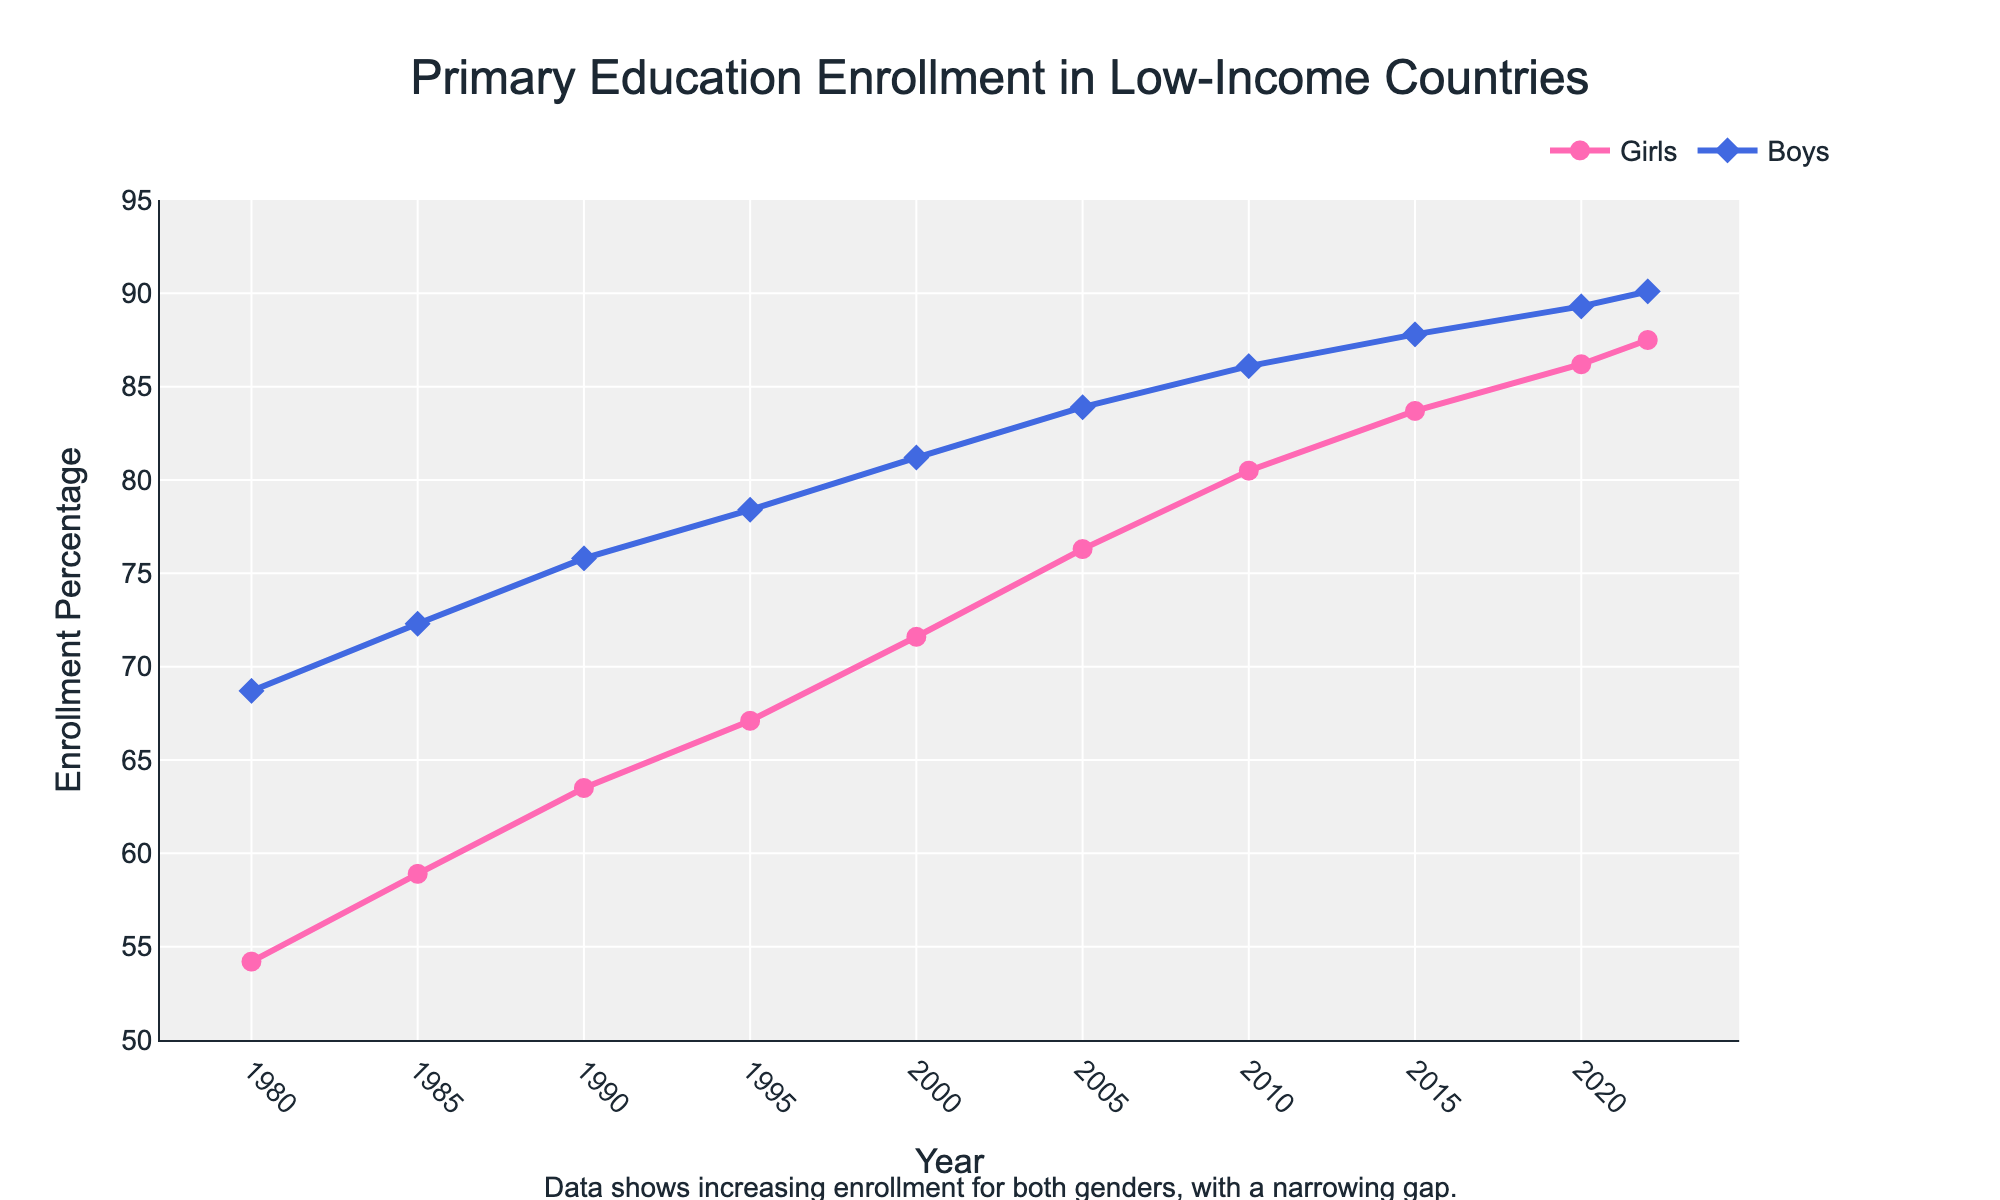What is the trend in primary education enrollment for girls from 1980 to 2022? The line chart shows an upward trend in the percentage of girls enrolled in primary education from 54.2% in 1980 to 87.5% in 2022.
Answer: Upward trend By how much did boys' primary education enrollment increase from 1980 to 2022? In 1980, boys' enrollment was 68.7%, and it increased to 90.1% in 2022. The increase is 90.1% - 68.7% = 21.4%.
Answer: 21.4% In which year was the enrollment percentage of girls closest to that of boys? The gap between boys and girls narrows over time. By examining the lines in 2022, we see that girls' enrollment is 87.5%, and boys' enrollment is 90.1%, the smallest gap.
Answer: 2022 How much did the enrollment percentage for girls increase on average each decade? From 1980 to 2022, girls' enrollment went from 54.2% to 87.5%. Over approximately four decades, the increase is 87.5% - 54.2% = 33.3%. The average increase per decade is 33.3% / 4 ≈ 8.33%.
Answer: 8.33% Which year showed the highest increase in girls' enrollment compared to the previous year? Looking at the increments: 1980-1985: 4.7, 1985-1990: 4.6, 1990-1995: 3.6, 1995-2000: 4.5, 2000-2005: 4.7, 2005-2010: 4.2, 2010-2015: 3.2, 2015-2020: 2.5, 2020-2022: 1.3. The highest increase occurred between 1980-1985 and 2000-2005, both being 4.7%.
Answer: 1980-1985 and 2000-2005 What is the difference in enrollment percentages between boys and girls in 1990 and 2020? In 1990, boys' enrollment was 75.8%, and girls' was 63.5%, a difference of 75.8% - 63.5% = 12.3%. In 2020, boys' enrollment was 89.3%, and girls' was 86.2%, a difference of 89.3% - 86.2% = 3.1%.
Answer: Difference decreased from 12.3% to 3.1% How did boys' enrollment change from 2000 to 2010? In 2000, boys' enrollment was 81.2%. By 2010, it had risen to 86.1%. The change is 86.1% - 81.2% = 4.9%.
Answer: Increase of 4.9% Which gender saw a faster rate of increase in enrollment between 1980 and 2022? Girls' enrollment increased from 54.2% to 87.5%, an increase of 33.3 percentage points. Boys' enrollment increased from 68.7% to 90.1%, an increase of 21.4 percentage points. Girls saw a faster rate of increase.
Answer: Girls What can be inferred about the gender gap in primary education enrollment over time? The visual annotation and the lines indicate a narrowing gap between the enrollment percentages of boys and girls over the years, illustrating improved gender parity.
Answer: Narrowing gap 